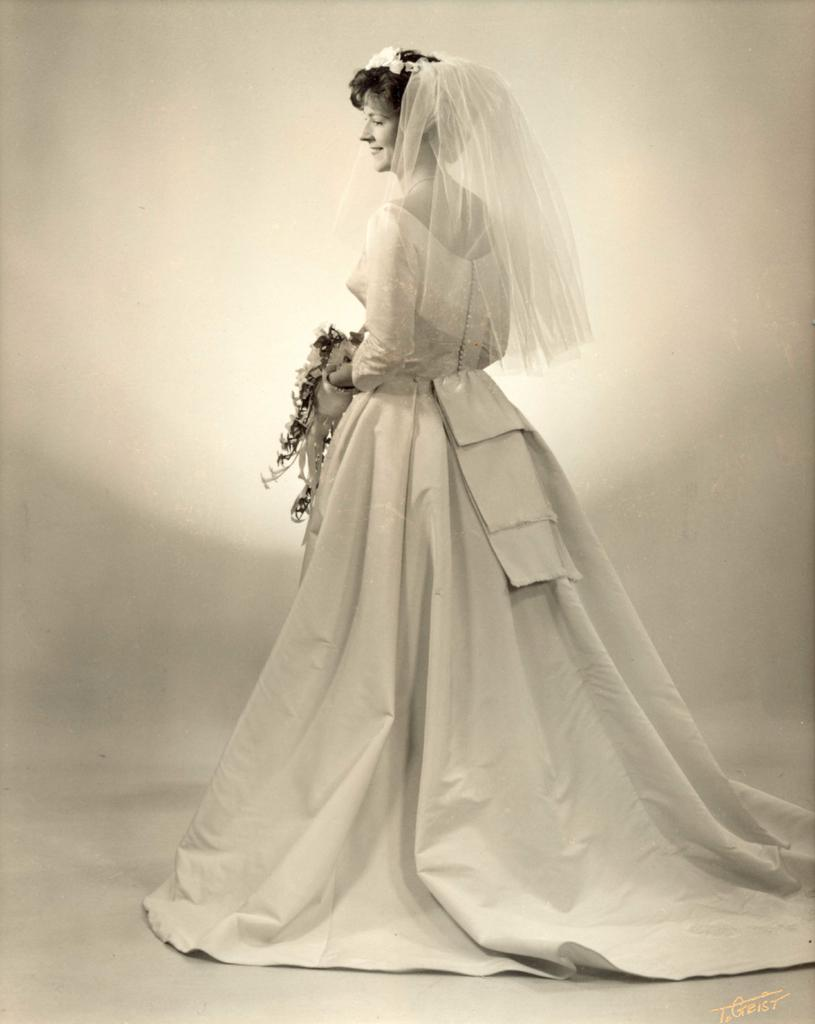Who is the main subject in the image? There is a woman in the image. What is the woman doing in the image? The woman is standing. What is the woman wearing on her head? The woman is wearing a veil. What color is the background of the image? The background of the image is white. What year is depicted in the image? There is no specific year depicted in the image; it is a photograph of a woman wearing a veil with a white background. What type of teeth can be seen in the image? There are no teeth visible in the image, as it features a woman wearing a veil with a white background. 